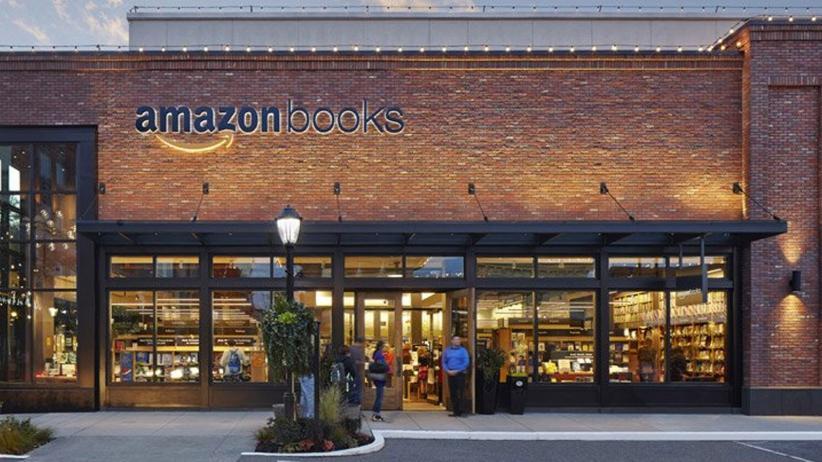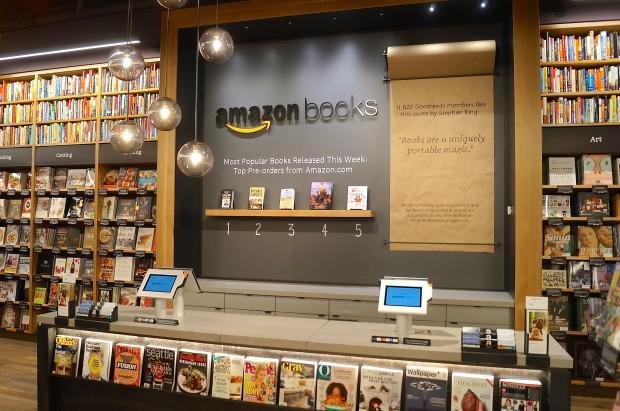The first image is the image on the left, the second image is the image on the right. Assess this claim about the two images: "One image shows the front entrance of an Amazon books store.". Correct or not? Answer yes or no. Yes. 